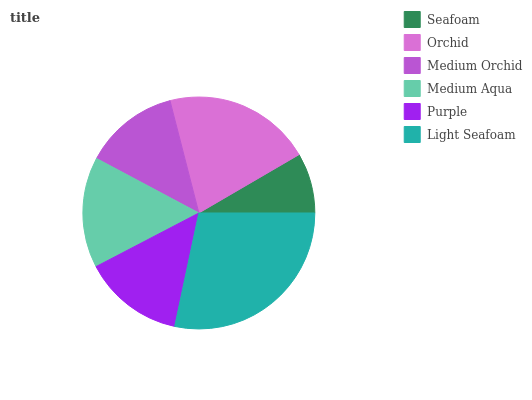Is Seafoam the minimum?
Answer yes or no. Yes. Is Light Seafoam the maximum?
Answer yes or no. Yes. Is Orchid the minimum?
Answer yes or no. No. Is Orchid the maximum?
Answer yes or no. No. Is Orchid greater than Seafoam?
Answer yes or no. Yes. Is Seafoam less than Orchid?
Answer yes or no. Yes. Is Seafoam greater than Orchid?
Answer yes or no. No. Is Orchid less than Seafoam?
Answer yes or no. No. Is Medium Aqua the high median?
Answer yes or no. Yes. Is Purple the low median?
Answer yes or no. Yes. Is Orchid the high median?
Answer yes or no. No. Is Medium Aqua the low median?
Answer yes or no. No. 